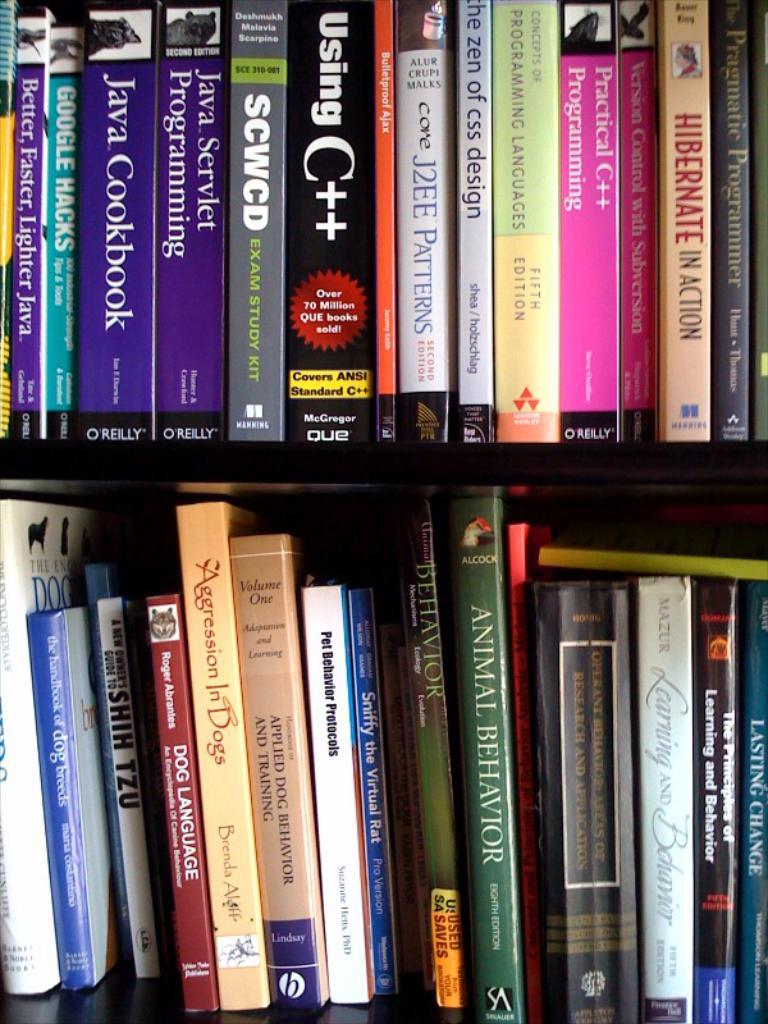Provide a one-sentence caption for the provided image. The title of the green book on the bottom self is called "Animal Behavior.". 